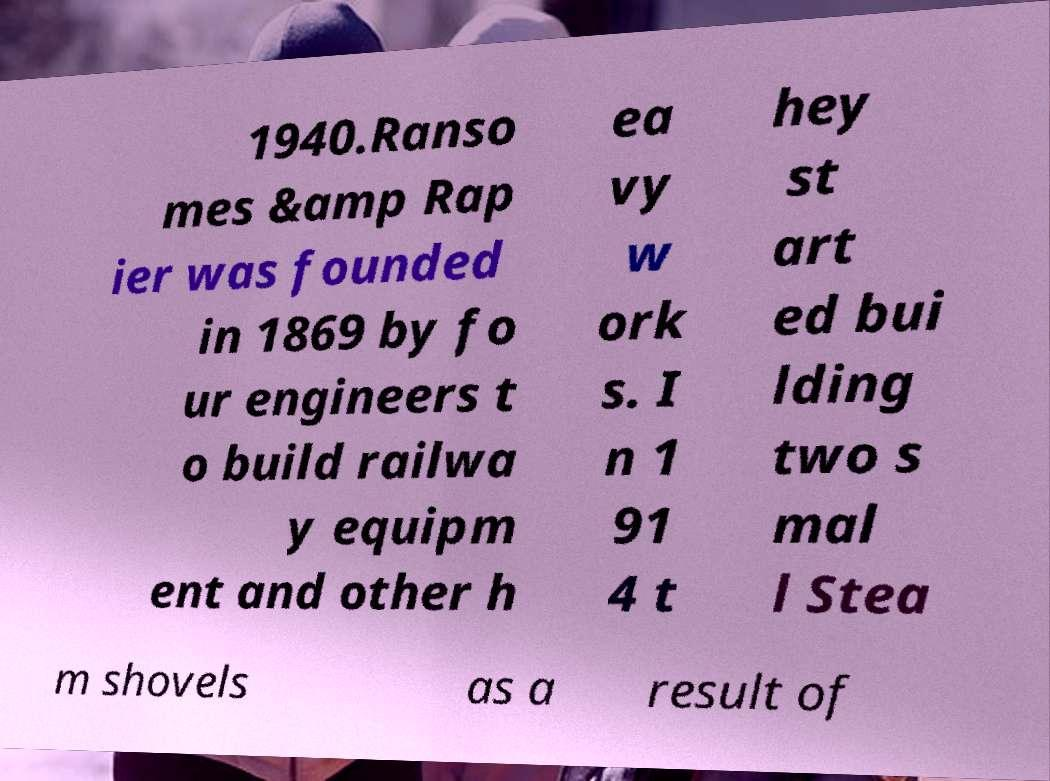For documentation purposes, I need the text within this image transcribed. Could you provide that? 1940.Ranso mes &amp Rap ier was founded in 1869 by fo ur engineers t o build railwa y equipm ent and other h ea vy w ork s. I n 1 91 4 t hey st art ed bui lding two s mal l Stea m shovels as a result of 